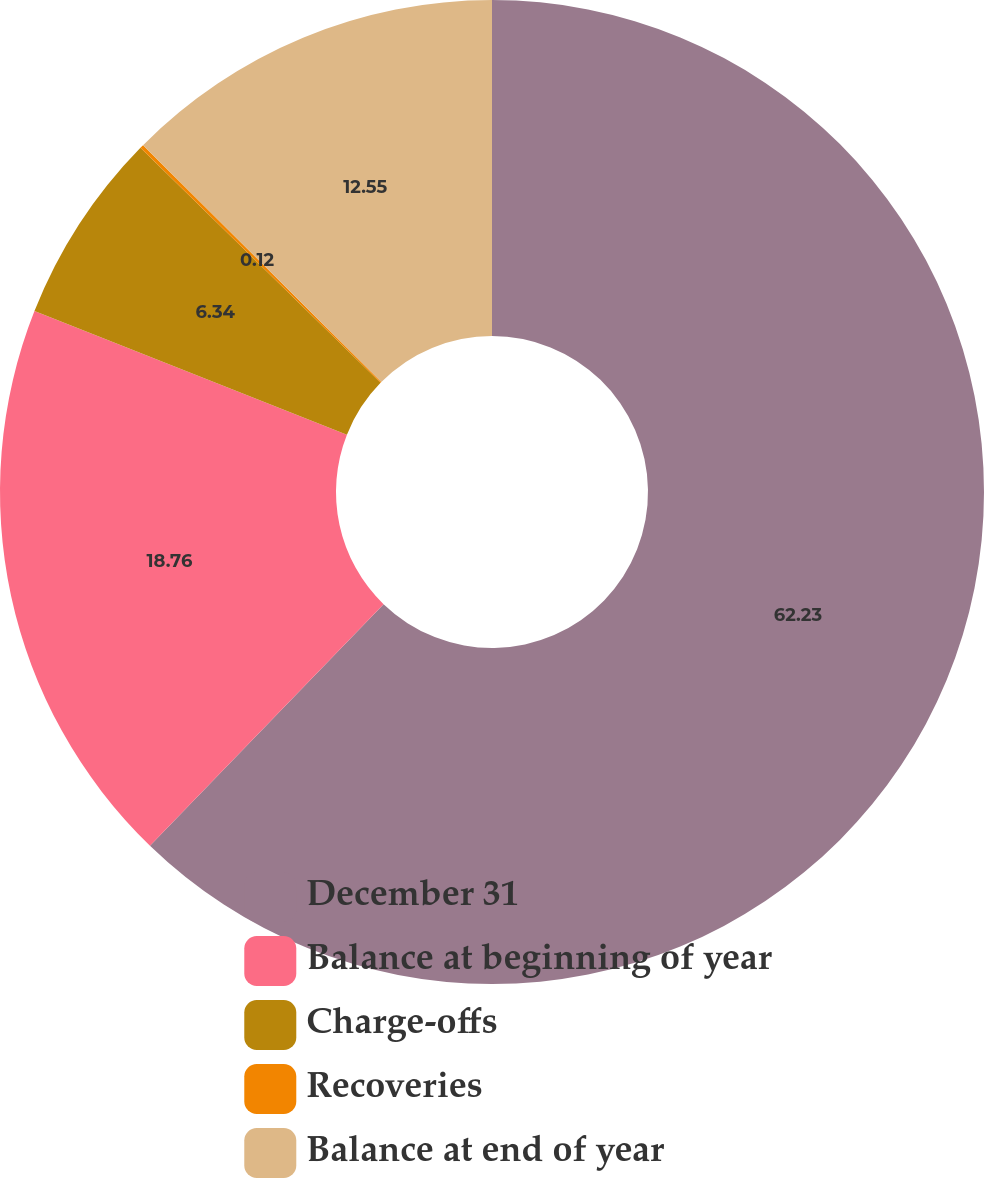Convert chart. <chart><loc_0><loc_0><loc_500><loc_500><pie_chart><fcel>December 31<fcel>Balance at beginning of year<fcel>Charge-offs<fcel>Recoveries<fcel>Balance at end of year<nl><fcel>62.24%<fcel>18.76%<fcel>6.34%<fcel>0.12%<fcel>12.55%<nl></chart> 